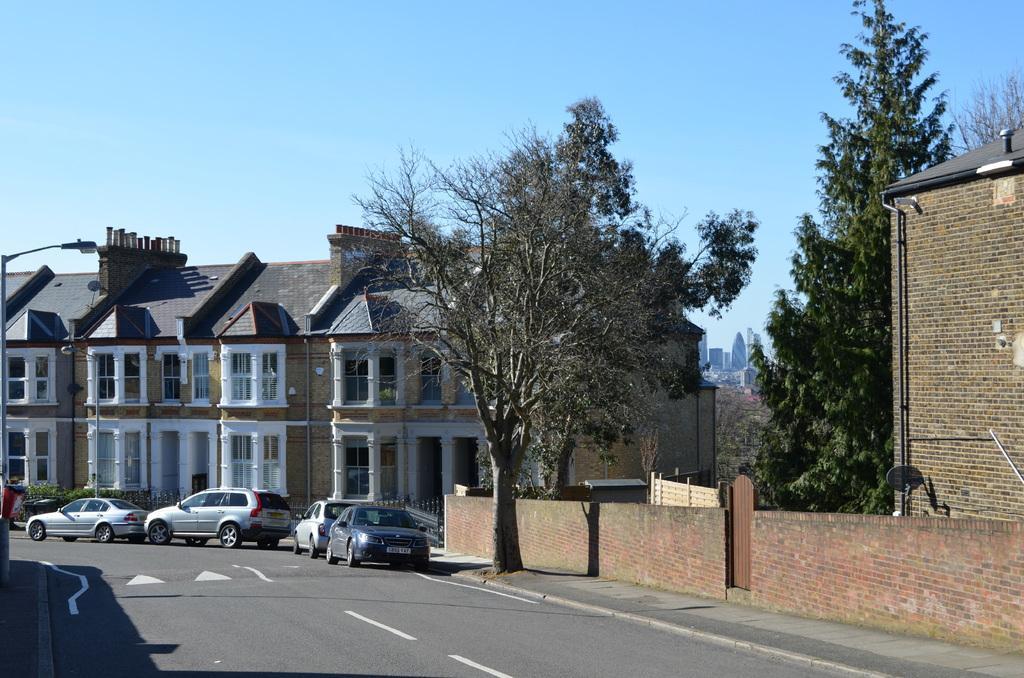How would you summarize this image in a sentence or two? In this image there are buildings and trees. At the bottom we can see cars on the road. In the background there is sky. On the left there is a pole. 